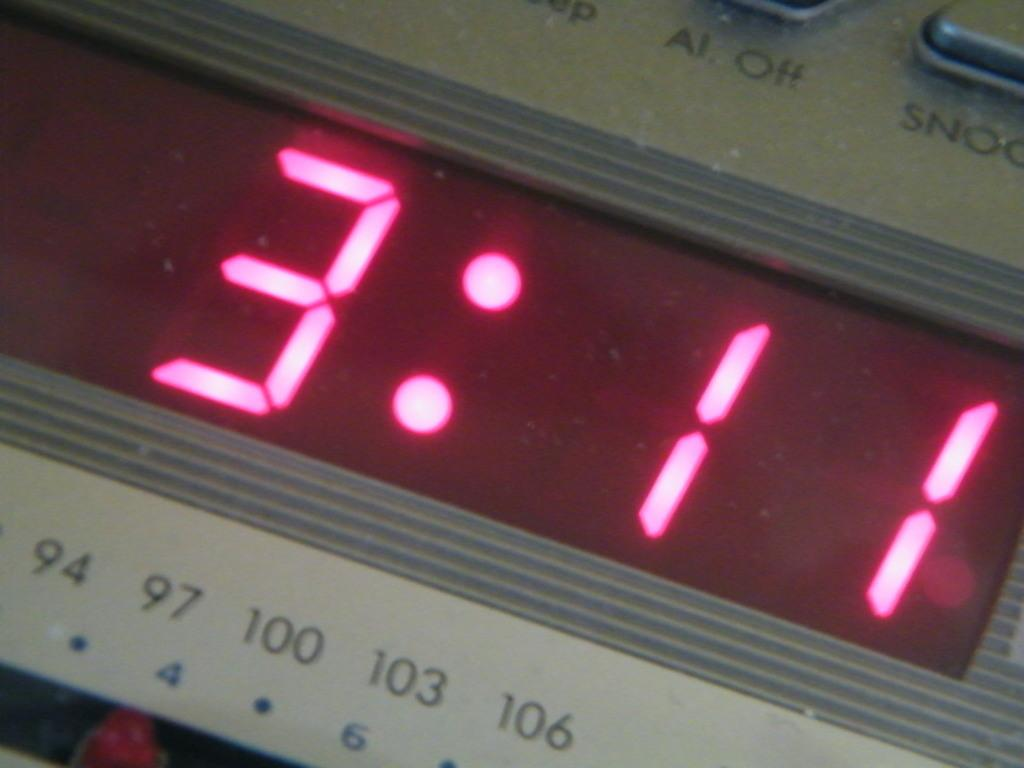<image>
Summarize the visual content of the image. an alarm that has the time of 3:11 on it 